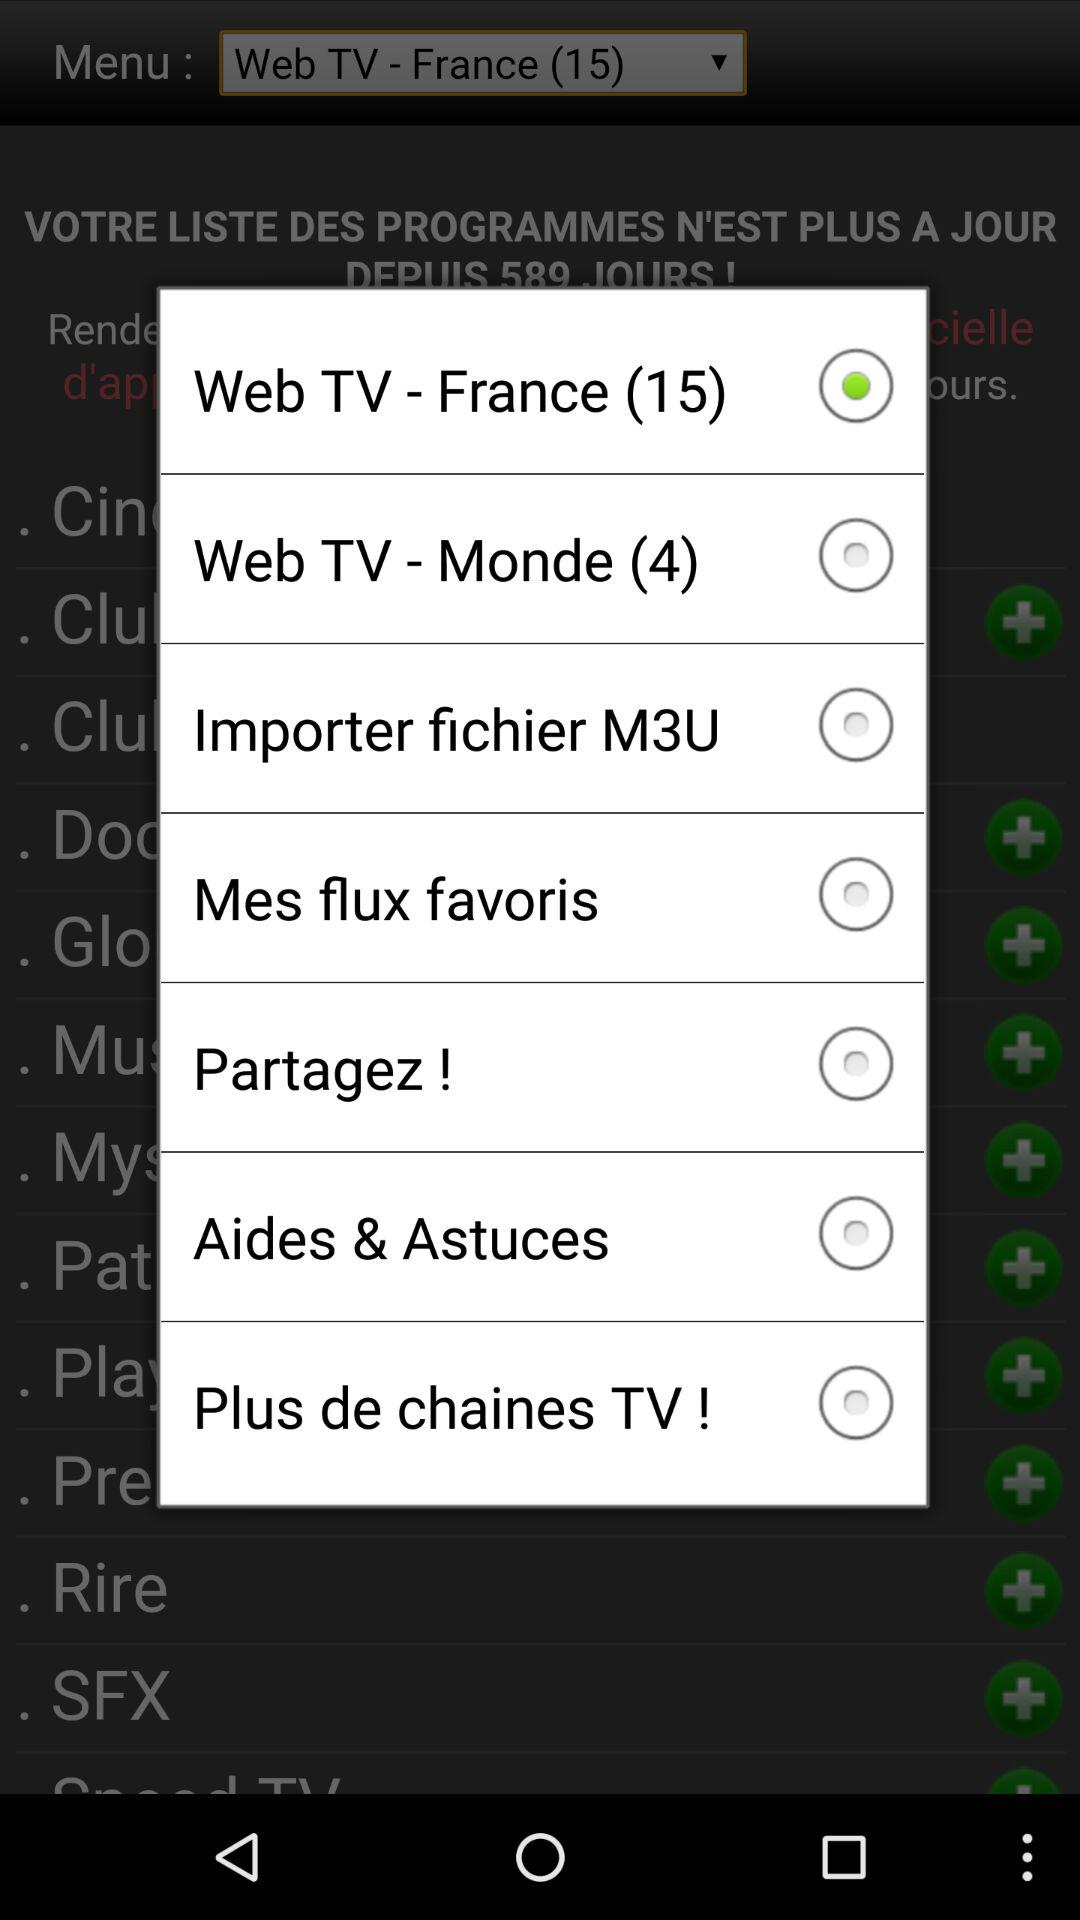Which radio button is selected? The selected radio button is "Web TV - France (15)". 